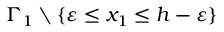Convert formula to latex. <formula><loc_0><loc_0><loc_500><loc_500>\Gamma _ { 1 } \ \{ \varepsilon \leq x _ { 1 } \leq h - \varepsilon \}</formula> 